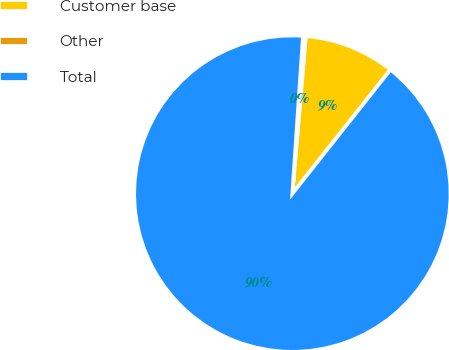<chart> <loc_0><loc_0><loc_500><loc_500><pie_chart><fcel>Customer base<fcel>Other<fcel>Total<nl><fcel>9.3%<fcel>0.28%<fcel>90.42%<nl></chart> 